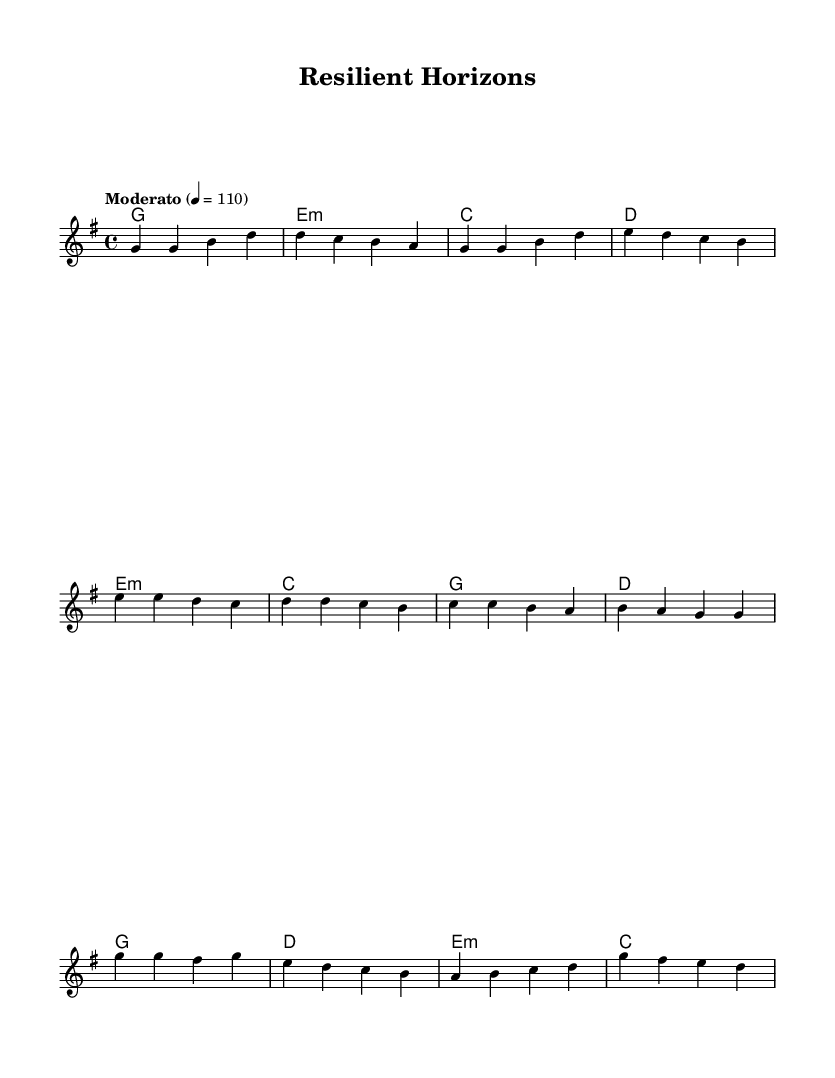What is the key signature of this music? The key signature is G major, which has one sharp (F#).
Answer: G major What is the time signature of this music? The time signature is 4/4, meaning there are four beats in each measure.
Answer: 4/4 What is the tempo marking of this music? The tempo marking is "Moderato," which indicates a moderate pace typically around 108 to 120 beats per minute.
Answer: Moderato What are the three main sections in this composition? The three main sections are the Verse, Pre-Chorus, and Chorus, identifiable by their distinct melodic lines and chord progressions.
Answer: Verse, Pre-Chorus, Chorus In the chorus, what is the first note of the melody? The first note of the melody in the chorus is G, which is the starting pitch of that section and sets the tone for that part of the song.
Answer: G How many measures are there in the verse part? There are eight measures in the verse part, evidenced by the four phrases each containing two measures.
Answer: 8 What kind of chord progression is used in the pre-chorus section? The chord progression in the pre-chorus is a minor chord (E minor) followed by a sequence of major chords (C, G, D), creating tension that leads to the chorus.
Answer: E minor, C, G, D 